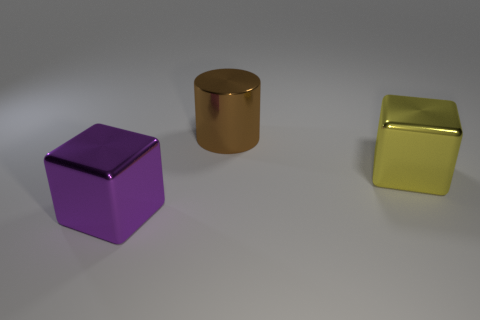Are there more metallic things behind the yellow metal cube than large purple objects behind the purple metal thing?
Make the answer very short. Yes. What is the shape of the large purple metal object?
Provide a succinct answer. Cube. What is the shape of the big metal object that is on the right side of the big shiny cylinder?
Your response must be concise. Cube. Is there anything else that has the same shape as the brown shiny thing?
Your response must be concise. No. Is there a large cube that is behind the thing that is on the left side of the large brown cylinder?
Make the answer very short. Yes. What color is the other thing that is the same shape as the purple thing?
Offer a terse response. Yellow. There is a large metal block right of the big metal object that is in front of the block that is behind the large purple metal block; what color is it?
Provide a short and direct response. Yellow. Does the large brown object have the same shape as the big yellow metal object?
Provide a succinct answer. No. Is the number of blocks that are right of the big brown metallic cylinder the same as the number of metal objects that are in front of the yellow object?
Keep it short and to the point. Yes. The other big block that is the same material as the yellow block is what color?
Ensure brevity in your answer.  Purple. 